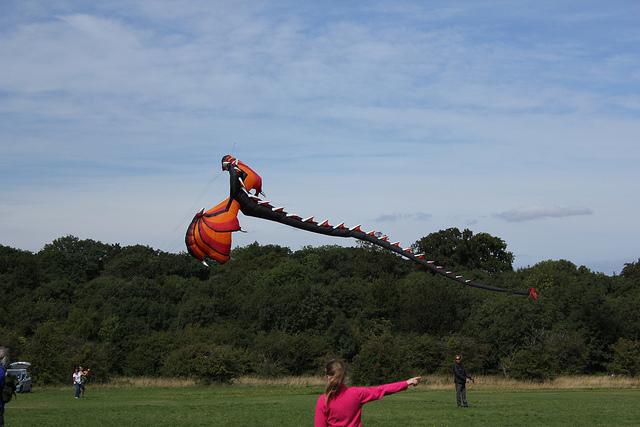Does the kite have a blue tail?
Concise answer only. No. Is it snowing?
Short answer required. No. Are there people in the picture?
Be succinct. Yes. 